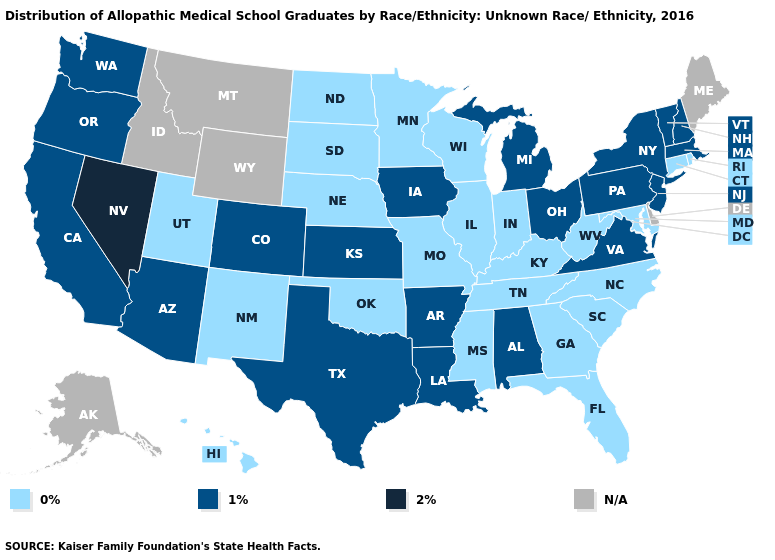Which states have the lowest value in the USA?
Keep it brief. Connecticut, Florida, Georgia, Hawaii, Illinois, Indiana, Kentucky, Maryland, Minnesota, Mississippi, Missouri, Nebraska, New Mexico, North Carolina, North Dakota, Oklahoma, Rhode Island, South Carolina, South Dakota, Tennessee, Utah, West Virginia, Wisconsin. Name the states that have a value in the range 1%?
Quick response, please. Alabama, Arizona, Arkansas, California, Colorado, Iowa, Kansas, Louisiana, Massachusetts, Michigan, New Hampshire, New Jersey, New York, Ohio, Oregon, Pennsylvania, Texas, Vermont, Virginia, Washington. What is the lowest value in the USA?
Short answer required. 0%. Name the states that have a value in the range N/A?
Write a very short answer. Alaska, Delaware, Idaho, Maine, Montana, Wyoming. What is the value of Maine?
Be succinct. N/A. What is the value of Oklahoma?
Be succinct. 0%. What is the value of Kentucky?
Write a very short answer. 0%. Does the map have missing data?
Quick response, please. Yes. What is the value of Louisiana?
Answer briefly. 1%. What is the lowest value in the USA?
Be succinct. 0%. Name the states that have a value in the range 1%?
Give a very brief answer. Alabama, Arizona, Arkansas, California, Colorado, Iowa, Kansas, Louisiana, Massachusetts, Michigan, New Hampshire, New Jersey, New York, Ohio, Oregon, Pennsylvania, Texas, Vermont, Virginia, Washington. Does the map have missing data?
Short answer required. Yes. Among the states that border Wyoming , does South Dakota have the lowest value?
Short answer required. Yes. 